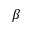<formula> <loc_0><loc_0><loc_500><loc_500>\beta</formula> 